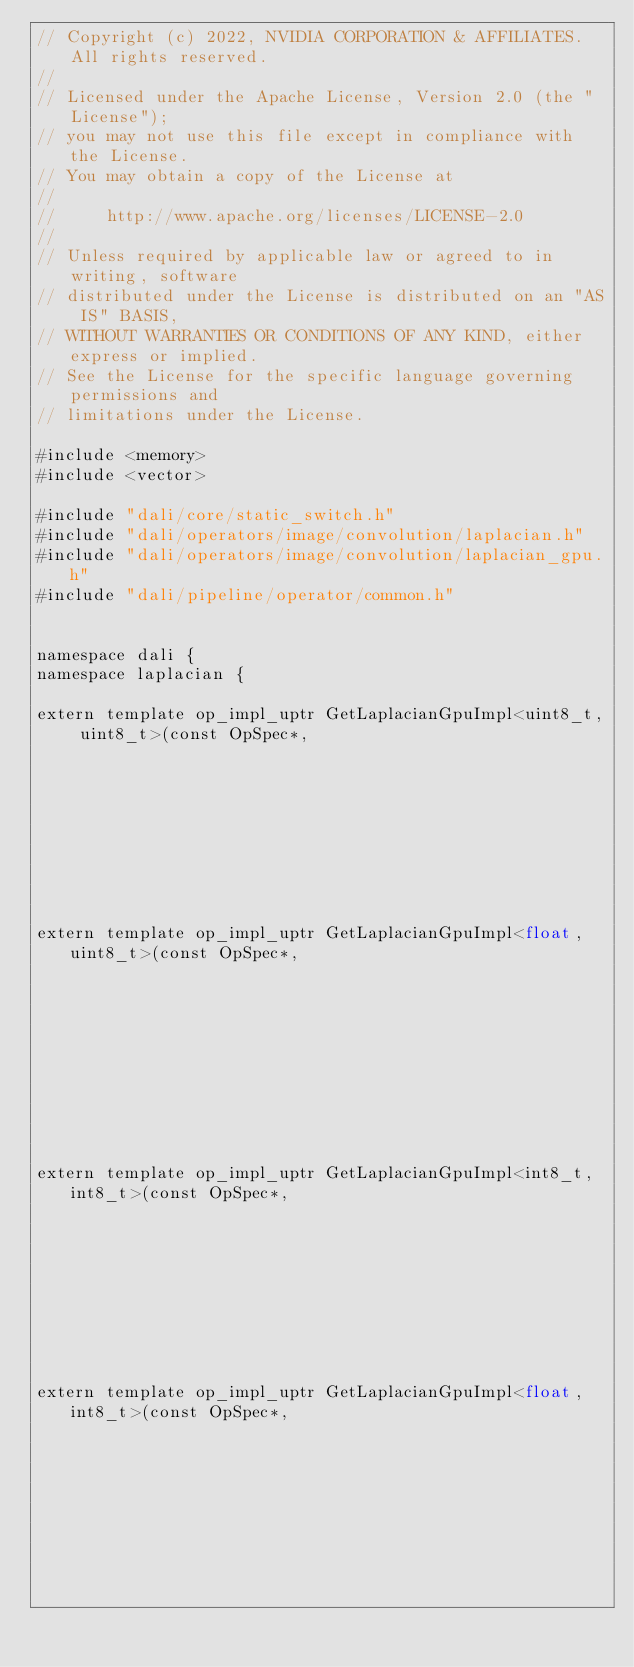<code> <loc_0><loc_0><loc_500><loc_500><_Cuda_>// Copyright (c) 2022, NVIDIA CORPORATION & AFFILIATES. All rights reserved.
//
// Licensed under the Apache License, Version 2.0 (the "License");
// you may not use this file except in compliance with the License.
// You may obtain a copy of the License at
//
//     http://www.apache.org/licenses/LICENSE-2.0
//
// Unless required by applicable law or agreed to in writing, software
// distributed under the License is distributed on an "AS IS" BASIS,
// WITHOUT WARRANTIES OR CONDITIONS OF ANY KIND, either express or implied.
// See the License for the specific language governing permissions and
// limitations under the License.

#include <memory>
#include <vector>

#include "dali/core/static_switch.h"
#include "dali/operators/image/convolution/laplacian.h"
#include "dali/operators/image/convolution/laplacian_gpu.h"
#include "dali/pipeline/operator/common.h"


namespace dali {
namespace laplacian {

extern template op_impl_uptr GetLaplacianGpuImpl<uint8_t, uint8_t>(const OpSpec*,
                                                                   const DimDesc& dim_desc);
extern template op_impl_uptr GetLaplacianGpuImpl<float, uint8_t>(const OpSpec*,
                                                                 const DimDesc& dim_desc);

extern template op_impl_uptr GetLaplacianGpuImpl<int8_t, int8_t>(const OpSpec*,
                                                                 const DimDesc& dim_desc);
extern template op_impl_uptr GetLaplacianGpuImpl<float, int8_t>(const OpSpec*,
                                                                const DimDesc& dim_desc);
</code> 